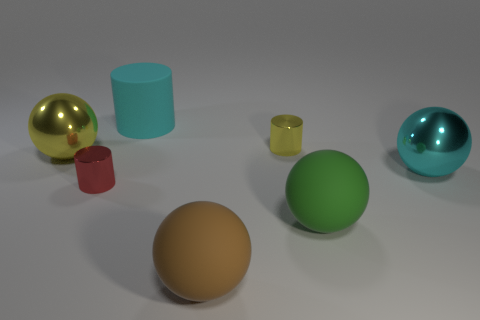Subtract all red metal cylinders. How many cylinders are left? 2 Add 3 large cyan rubber things. How many objects exist? 10 Subtract all brown balls. How many balls are left? 3 Subtract 2 cylinders. How many cylinders are left? 1 Subtract all spheres. How many objects are left? 3 Subtract all red balls. Subtract all gray cylinders. How many balls are left? 4 Add 2 cyan shiny objects. How many cyan shiny objects are left? 3 Add 6 tiny red things. How many tiny red things exist? 7 Subtract 1 cyan cylinders. How many objects are left? 6 Subtract all big cyan cylinders. Subtract all large cyan matte things. How many objects are left? 5 